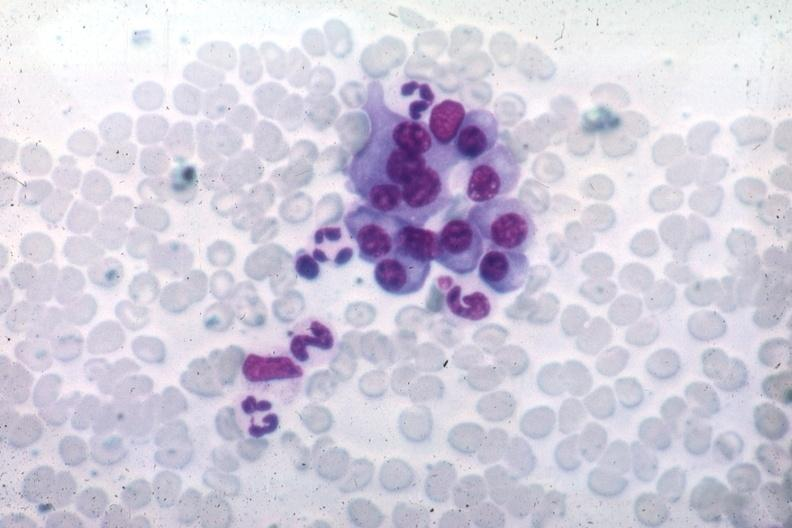s hematologic present?
Answer the question using a single word or phrase. Yes 